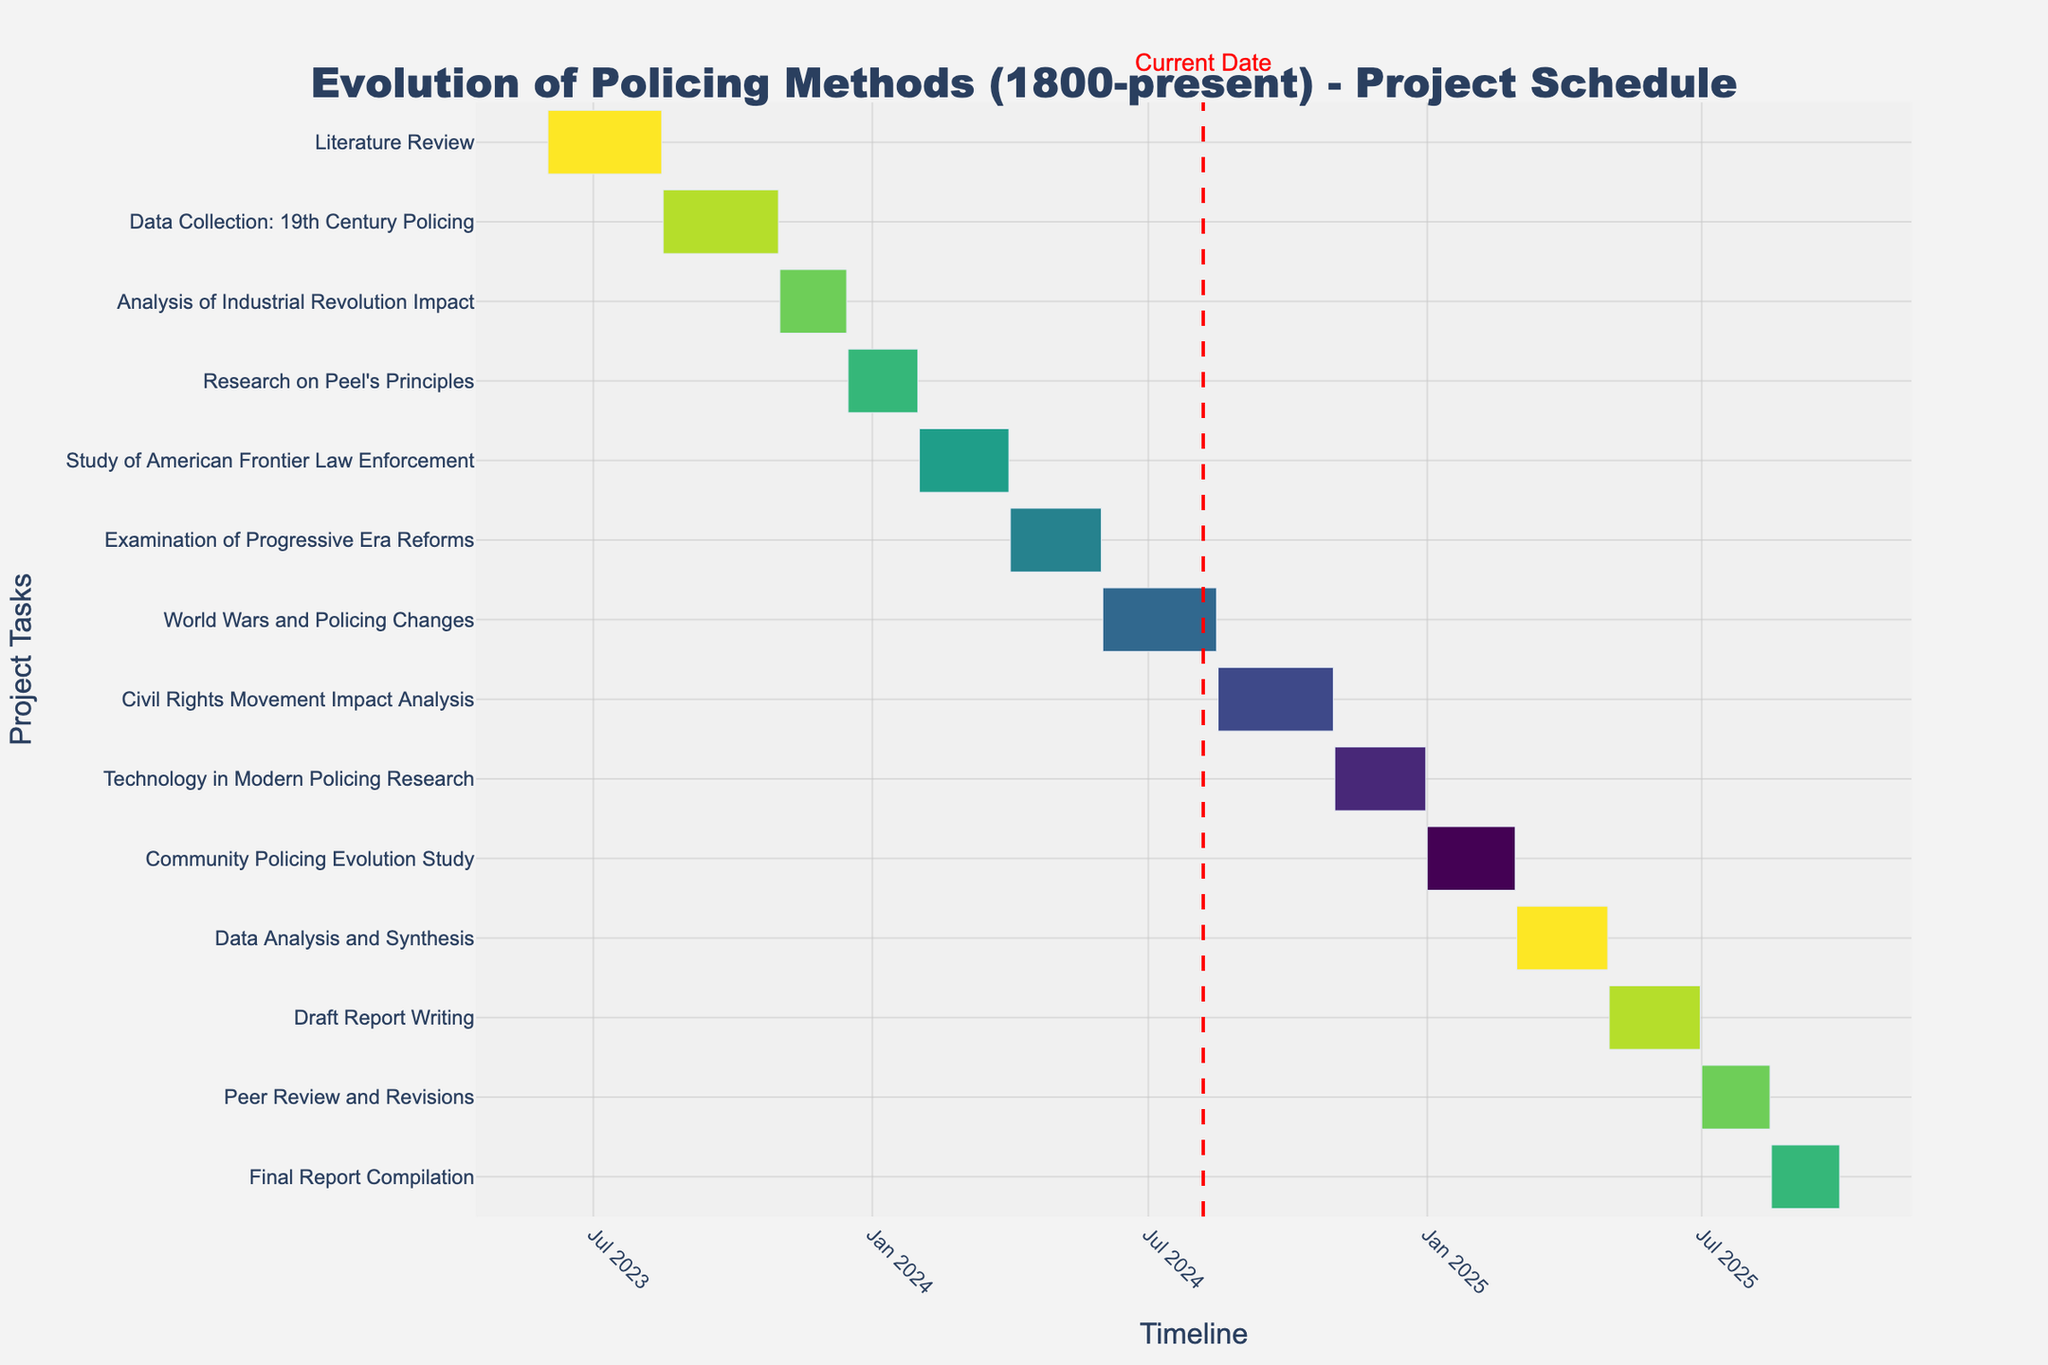What is the title of the Gantt Chart? The title of the chart is displayed prominently at the top and provides a summary of the project's focus and scope.
Answer: Evolution of Policing Methods (1800-present) - Project Schedule Which task has the longest duration? To determine the task with the longest duration, look at the lengths of the horizontal bars and compare them. The task with the longest bar has the longest duration.
Answer: Peer Review and Revisions When does the "Data Collection: 19th Century Policing" task start and end? The start and end dates for the task can be found by looking at the horizontal bar labeled "Data Collection: 19th Century Policing" and checking its starting and ending points on the timeline.
Answer: Starts on 2023-08-16 and ends on 2023-10-31 How many months does the "Civil Rights Movement Impact Analysis" task span? To determine the number of months for this task, calculate the time difference between the start and end dates and convert it to months. This can be found by observing the horizontal bar for this task.
Answer: Approximately 2.5 months Which task is scheduled to start immediately after the "Study of American Frontier Law Enforcement"? Look at the timeline to find the end date of the "Study of American Frontier Law Enforcement" task, and identify the task that starts directly after this end date.
Answer: Examination of Progressive Era Reforms What is the total duration for the "Draft Report Writing" task? Calculate the total duration by finding the difference between the start and end dates of this task. This can be observed by looking at the length of the corresponding horizontal bar.
Answer: 2 months Which two tasks are shortest in duration? Determine the shortest tasks by comparing the lengths of all horizontal bars and identifying the two shortest ones.
Answer: Draft Report Writing and Technology in Modern Policing Research Which task overlaps with the "World Wars and Policing Changes" task at any point? Check the timeline and observe which other tasks' horizontal bars intersect with the timeline of the "World Wars and Policing Changes" task.
Answer: Civil Rights Movement Impact Analysis How many tasks are scheduled to be completed by the end of 2024? Count the number of tasks that have their end dates before or on December 31, 2024, by observing the endpoints of the horizontal bars on the timeline.
Answer: 7 tasks When does the "Final Report Compilation" task begin, and how long does it last? Identify the start date and calculate the duration of the task by looking at the start point and the length of its horizontal bar on the timeline.
Answer: Begins on 2025-08-16 and lasts about 1.5 months 